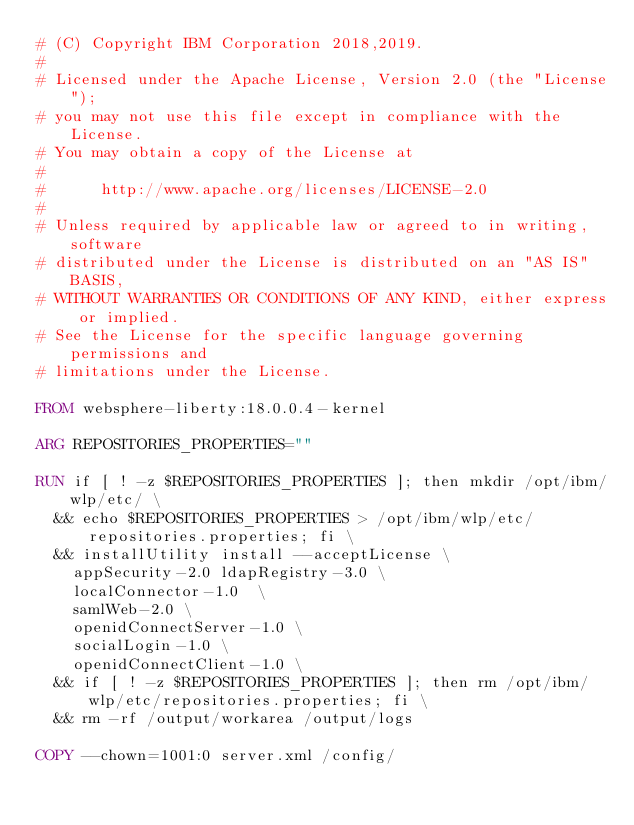<code> <loc_0><loc_0><loc_500><loc_500><_Dockerfile_># (C) Copyright IBM Corporation 2018,2019.
#
# Licensed under the Apache License, Version 2.0 (the "License");
# you may not use this file except in compliance with the License.
# You may obtain a copy of the License at
#
#      http://www.apache.org/licenses/LICENSE-2.0
#
# Unless required by applicable law or agreed to in writing, software
# distributed under the License is distributed on an "AS IS" BASIS,
# WITHOUT WARRANTIES OR CONDITIONS OF ANY KIND, either express or implied.
# See the License for the specific language governing permissions and
# limitations under the License.

FROM websphere-liberty:18.0.0.4-kernel

ARG REPOSITORIES_PROPERTIES=""

RUN if [ ! -z $REPOSITORIES_PROPERTIES ]; then mkdir /opt/ibm/wlp/etc/ \
  && echo $REPOSITORIES_PROPERTIES > /opt/ibm/wlp/etc/repositories.properties; fi \
  && installUtility install --acceptLicense \
    appSecurity-2.0 ldapRegistry-3.0 \
    localConnector-1.0  \
    samlWeb-2.0 \
    openidConnectServer-1.0 \
    socialLogin-1.0 \
    openidConnectClient-1.0 \
  && if [ ! -z $REPOSITORIES_PROPERTIES ]; then rm /opt/ibm/wlp/etc/repositories.properties; fi \
  && rm -rf /output/workarea /output/logs

COPY --chown=1001:0 server.xml /config/
</code> 